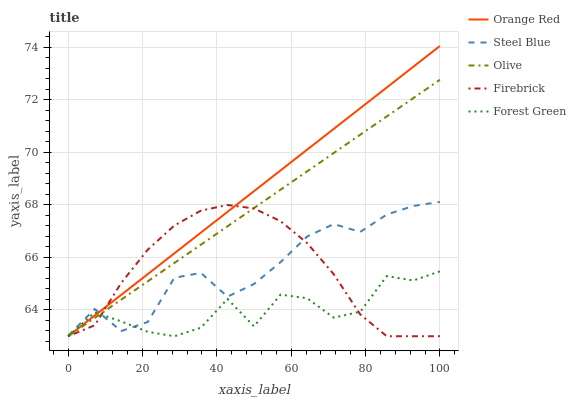Does Forest Green have the minimum area under the curve?
Answer yes or no. Yes. Does Orange Red have the maximum area under the curve?
Answer yes or no. Yes. Does Firebrick have the minimum area under the curve?
Answer yes or no. No. Does Firebrick have the maximum area under the curve?
Answer yes or no. No. Is Orange Red the smoothest?
Answer yes or no. Yes. Is Forest Green the roughest?
Answer yes or no. Yes. Is Firebrick the smoothest?
Answer yes or no. No. Is Firebrick the roughest?
Answer yes or no. No. Does Olive have the lowest value?
Answer yes or no. Yes. Does Steel Blue have the lowest value?
Answer yes or no. No. Does Orange Red have the highest value?
Answer yes or no. Yes. Does Firebrick have the highest value?
Answer yes or no. No. Does Steel Blue intersect Orange Red?
Answer yes or no. Yes. Is Steel Blue less than Orange Red?
Answer yes or no. No. Is Steel Blue greater than Orange Red?
Answer yes or no. No. 